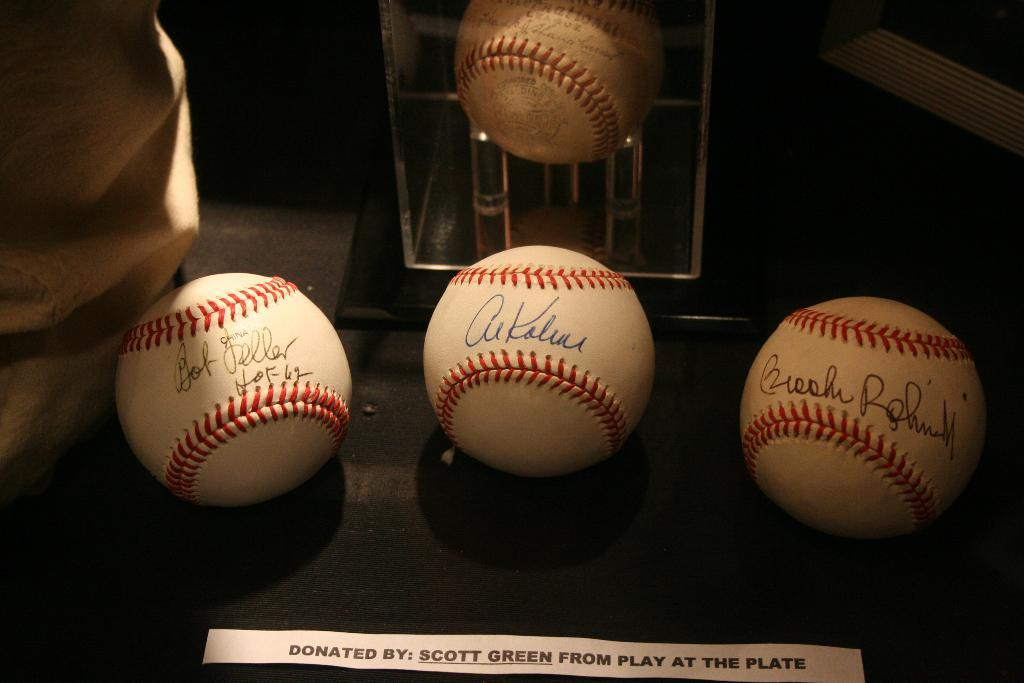<image>
Offer a succinct explanation of the picture presented. Several baseballs on display that were donated from play at the plate. 